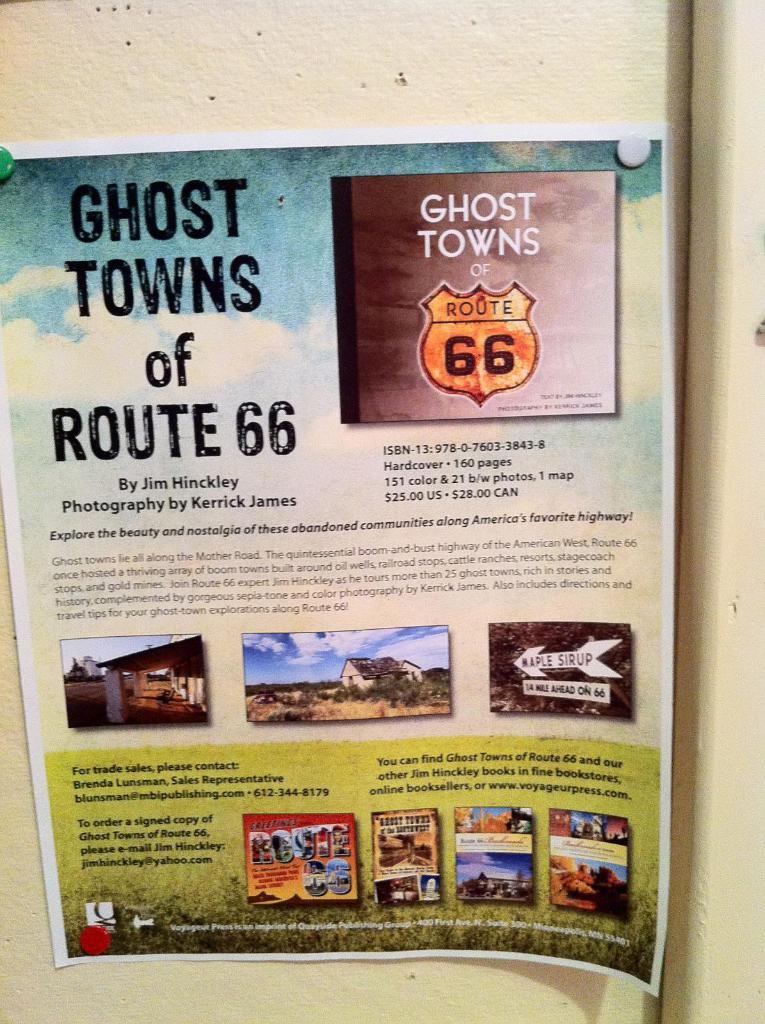What road are these ghost towns along?
Offer a very short reply. Route 66. What kind of town is advertised?
Give a very brief answer. Ghost towns. 